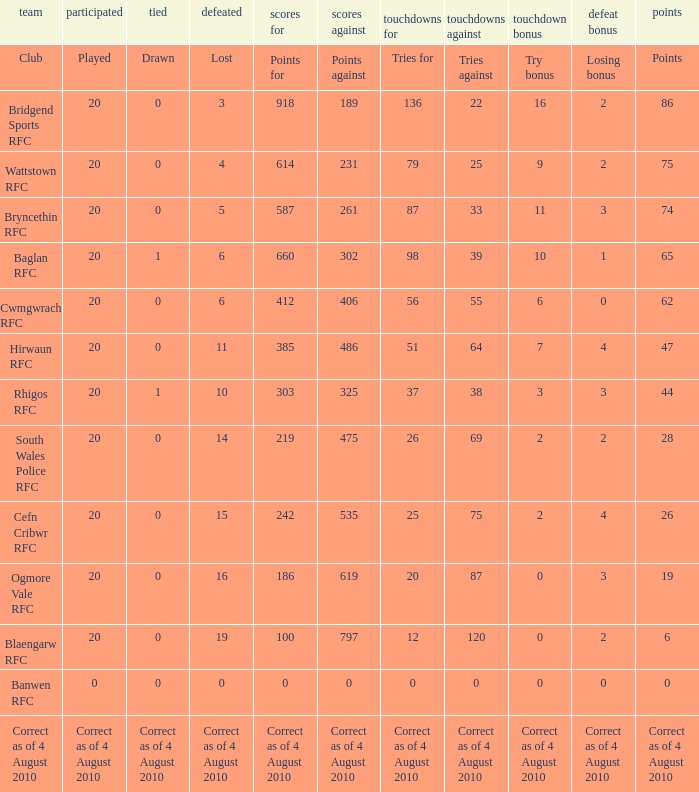What is drawn when the club is hirwaun rfc? 0.0. 